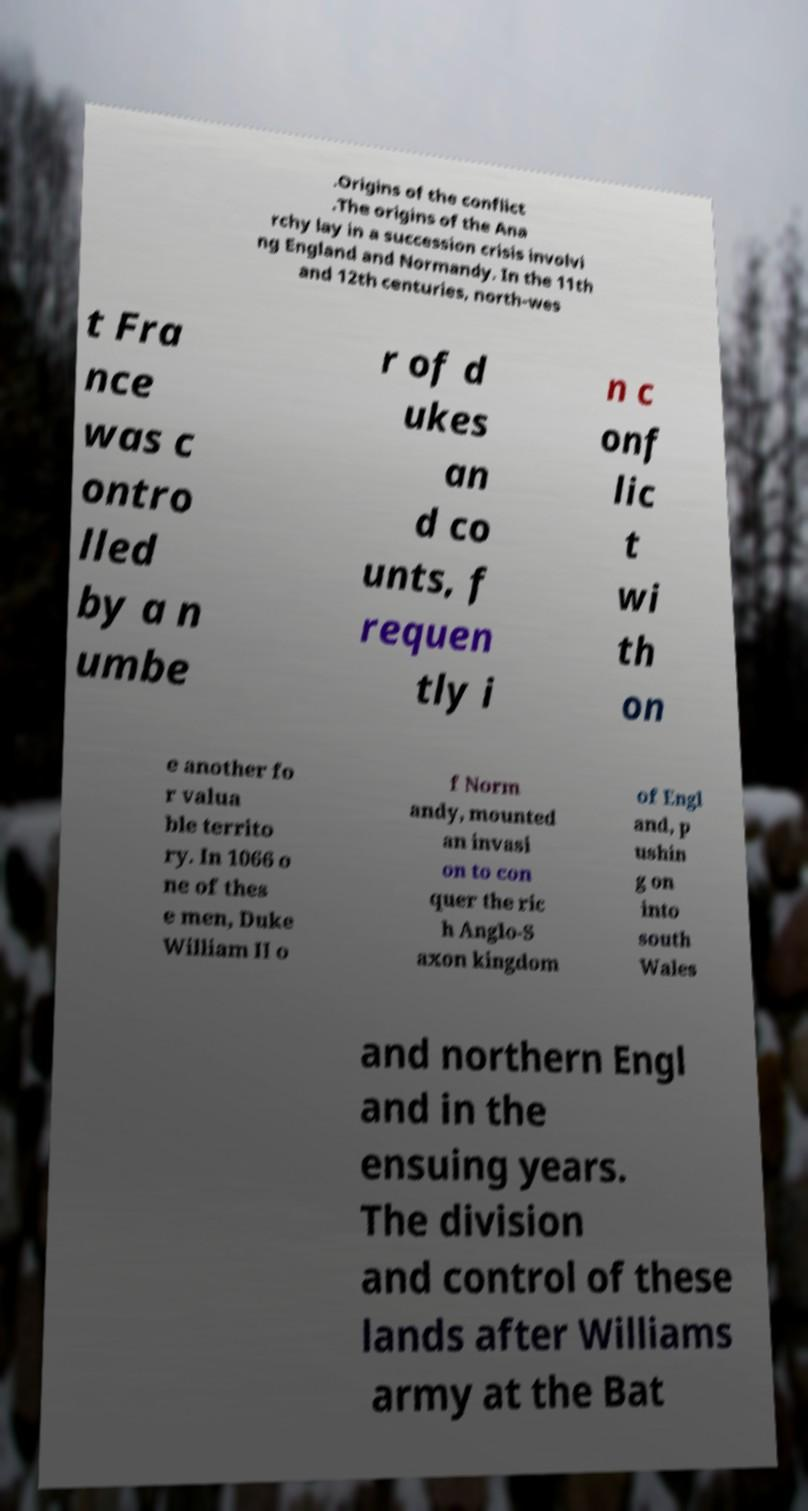Can you accurately transcribe the text from the provided image for me? .Origins of the conflict .The origins of the Ana rchy lay in a succession crisis involvi ng England and Normandy. In the 11th and 12th centuries, north-wes t Fra nce was c ontro lled by a n umbe r of d ukes an d co unts, f requen tly i n c onf lic t wi th on e another fo r valua ble territo ry. In 1066 o ne of thes e men, Duke William II o f Norm andy, mounted an invasi on to con quer the ric h Anglo-S axon kingdom of Engl and, p ushin g on into south Wales and northern Engl and in the ensuing years. The division and control of these lands after Williams army at the Bat 